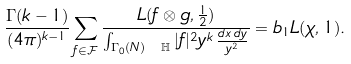<formula> <loc_0><loc_0><loc_500><loc_500>\frac { \Gamma ( k - 1 ) } { ( 4 \pi ) ^ { k - 1 } } \sum _ { f \in \mathcal { F } } \frac { L ( f \otimes g , \frac { 1 } { 2 } ) } { \int _ { \Gamma _ { 0 } ( N ) \ \mathbb { H } } | f | ^ { 2 } y ^ { k } \, \frac { d x \, d y } { y ^ { 2 } } } = b _ { 1 } L ( \chi , 1 ) .</formula> 